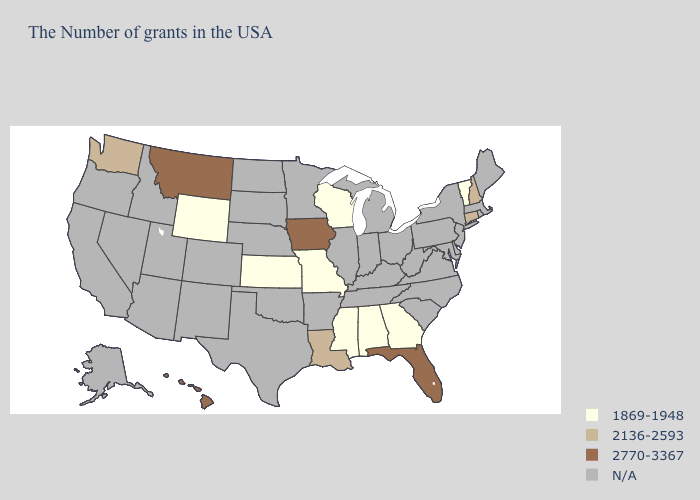Name the states that have a value in the range N/A?
Quick response, please. Maine, Massachusetts, Rhode Island, New York, New Jersey, Delaware, Maryland, Pennsylvania, Virginia, North Carolina, South Carolina, West Virginia, Ohio, Michigan, Kentucky, Indiana, Tennessee, Illinois, Arkansas, Minnesota, Nebraska, Oklahoma, Texas, South Dakota, North Dakota, Colorado, New Mexico, Utah, Arizona, Idaho, Nevada, California, Oregon, Alaska. What is the highest value in the South ?
Write a very short answer. 2770-3367. What is the value of Iowa?
Give a very brief answer. 2770-3367. Name the states that have a value in the range N/A?
Short answer required. Maine, Massachusetts, Rhode Island, New York, New Jersey, Delaware, Maryland, Pennsylvania, Virginia, North Carolina, South Carolina, West Virginia, Ohio, Michigan, Kentucky, Indiana, Tennessee, Illinois, Arkansas, Minnesota, Nebraska, Oklahoma, Texas, South Dakota, North Dakota, Colorado, New Mexico, Utah, Arizona, Idaho, Nevada, California, Oregon, Alaska. How many symbols are there in the legend?
Keep it brief. 4. Is the legend a continuous bar?
Be succinct. No. Name the states that have a value in the range N/A?
Be succinct. Maine, Massachusetts, Rhode Island, New York, New Jersey, Delaware, Maryland, Pennsylvania, Virginia, North Carolina, South Carolina, West Virginia, Ohio, Michigan, Kentucky, Indiana, Tennessee, Illinois, Arkansas, Minnesota, Nebraska, Oklahoma, Texas, South Dakota, North Dakota, Colorado, New Mexico, Utah, Arizona, Idaho, Nevada, California, Oregon, Alaska. Name the states that have a value in the range 1869-1948?
Answer briefly. Vermont, Georgia, Alabama, Wisconsin, Mississippi, Missouri, Kansas, Wyoming. What is the lowest value in the USA?
Give a very brief answer. 1869-1948. Does Louisiana have the highest value in the USA?
Be succinct. No. What is the lowest value in the West?
Write a very short answer. 1869-1948. What is the value of Ohio?
Be succinct. N/A. Does Vermont have the highest value in the Northeast?
Quick response, please. No. What is the value of New York?
Give a very brief answer. N/A. 